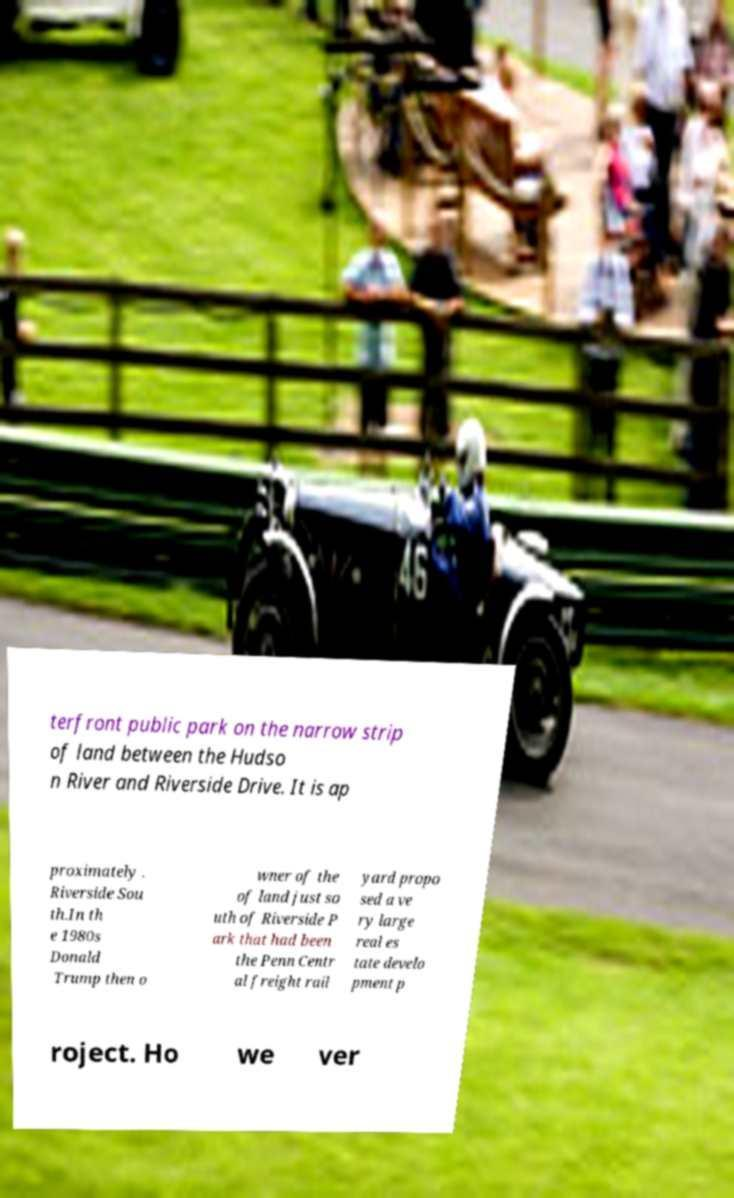Please identify and transcribe the text found in this image. terfront public park on the narrow strip of land between the Hudso n River and Riverside Drive. It is ap proximately . Riverside Sou th.In th e 1980s Donald Trump then o wner of the of land just so uth of Riverside P ark that had been the Penn Centr al freight rail yard propo sed a ve ry large real es tate develo pment p roject. Ho we ver 